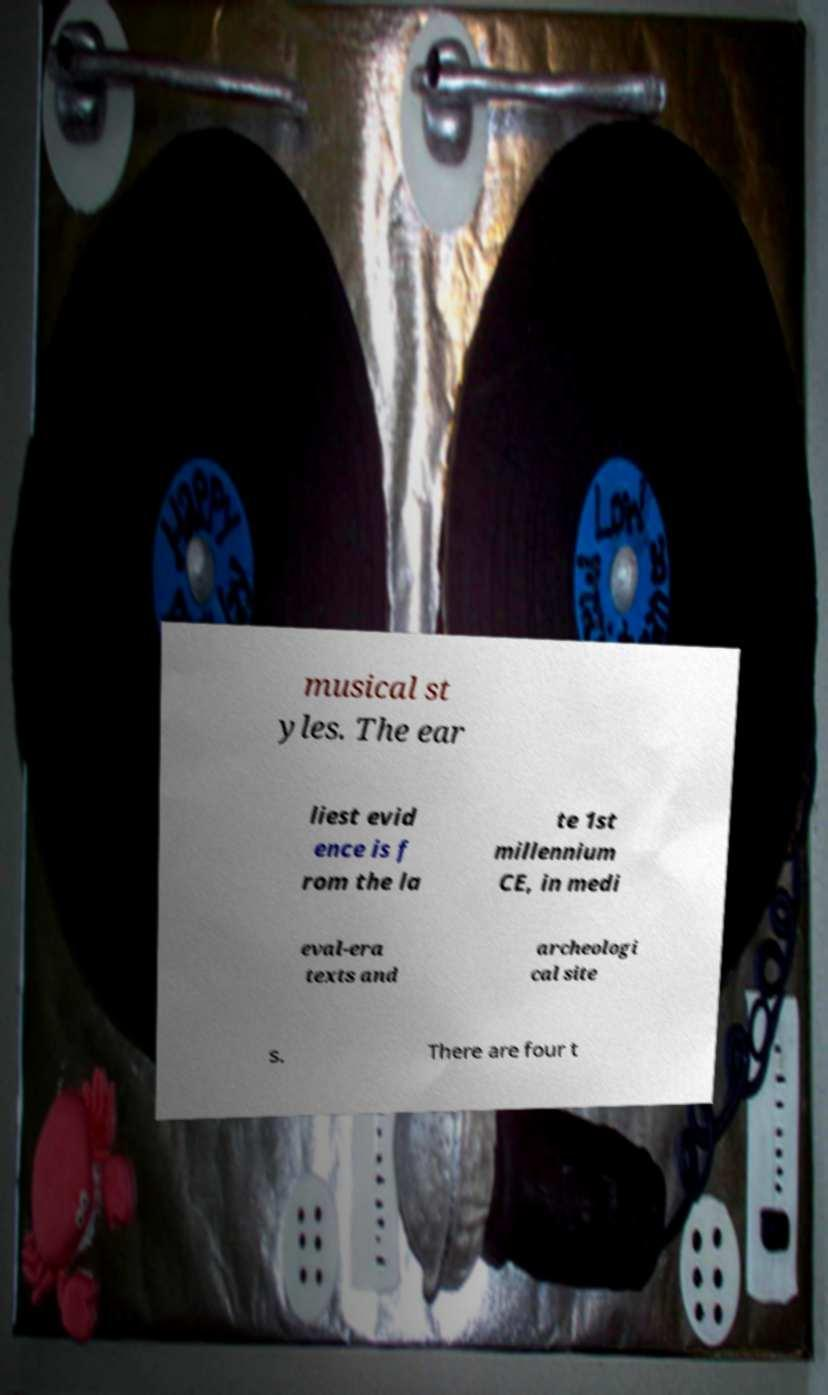Can you read and provide the text displayed in the image?This photo seems to have some interesting text. Can you extract and type it out for me? musical st yles. The ear liest evid ence is f rom the la te 1st millennium CE, in medi eval-era texts and archeologi cal site s. There are four t 